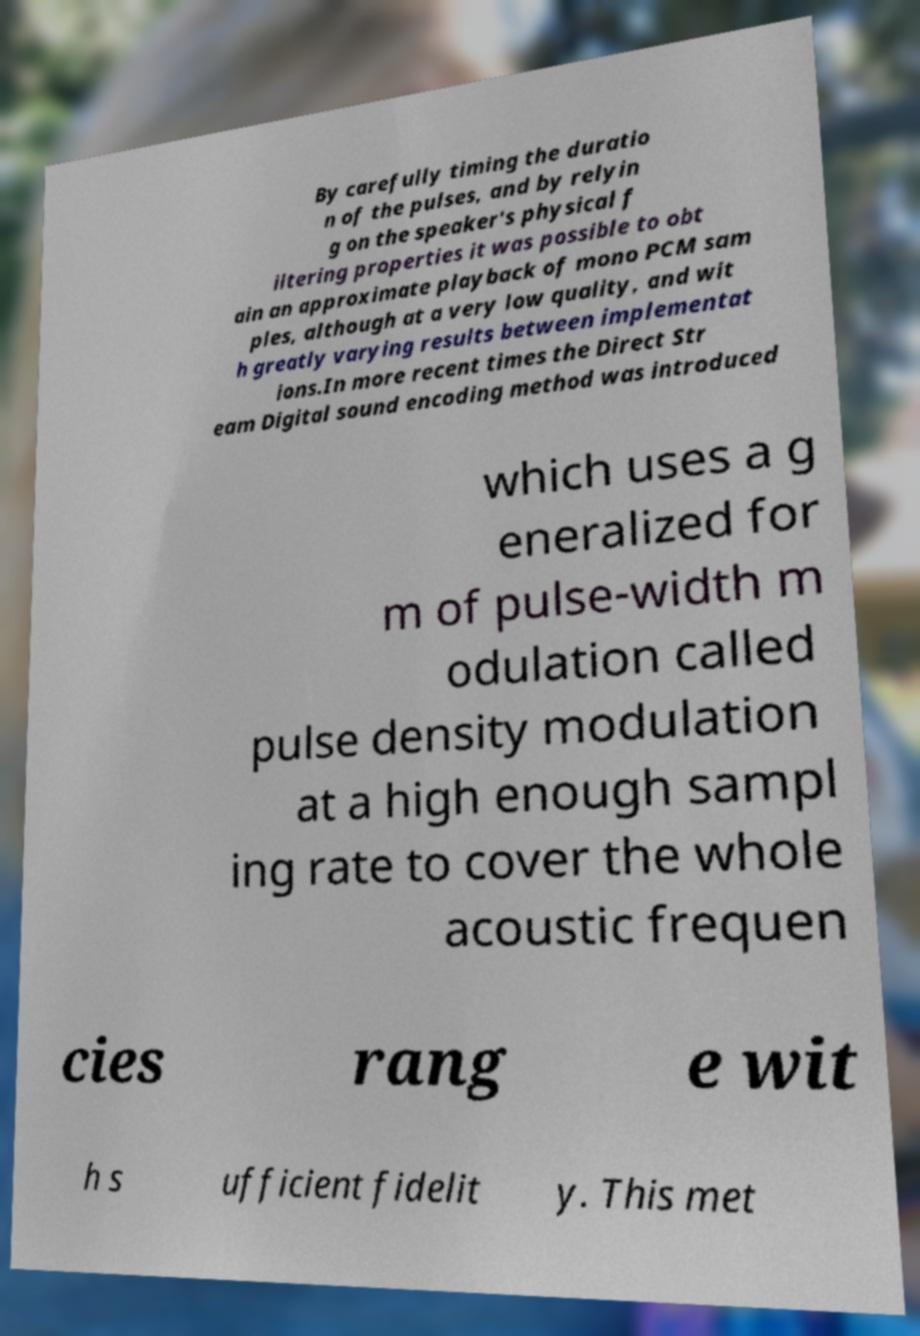For documentation purposes, I need the text within this image transcribed. Could you provide that? By carefully timing the duratio n of the pulses, and by relyin g on the speaker's physical f iltering properties it was possible to obt ain an approximate playback of mono PCM sam ples, although at a very low quality, and wit h greatly varying results between implementat ions.In more recent times the Direct Str eam Digital sound encoding method was introduced which uses a g eneralized for m of pulse-width m odulation called pulse density modulation at a high enough sampl ing rate to cover the whole acoustic frequen cies rang e wit h s ufficient fidelit y. This met 